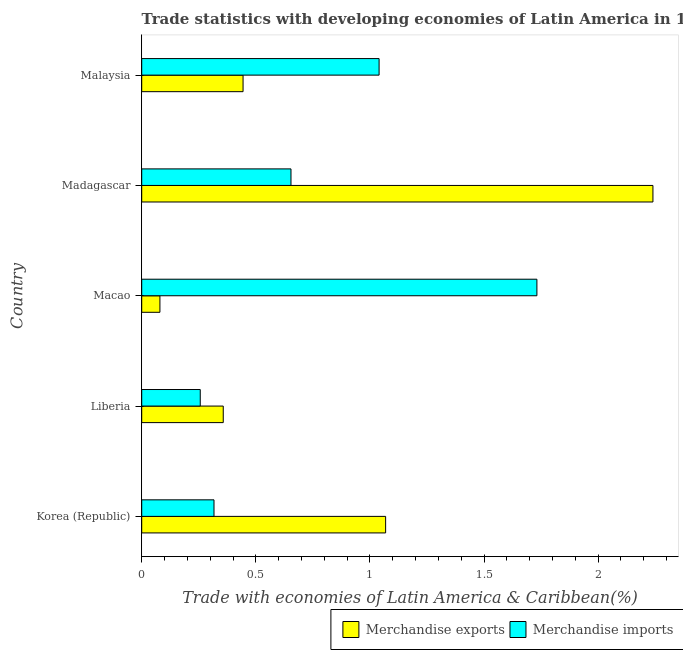How many different coloured bars are there?
Keep it short and to the point. 2. How many groups of bars are there?
Your answer should be compact. 5. How many bars are there on the 1st tick from the bottom?
Keep it short and to the point. 2. What is the label of the 5th group of bars from the top?
Your response must be concise. Korea (Republic). What is the merchandise imports in Liberia?
Offer a very short reply. 0.26. Across all countries, what is the maximum merchandise exports?
Ensure brevity in your answer.  2.24. Across all countries, what is the minimum merchandise exports?
Ensure brevity in your answer.  0.08. In which country was the merchandise imports maximum?
Make the answer very short. Macao. In which country was the merchandise exports minimum?
Ensure brevity in your answer.  Macao. What is the total merchandise imports in the graph?
Your answer should be compact. 4. What is the difference between the merchandise imports in Liberia and that in Malaysia?
Your answer should be compact. -0.78. What is the difference between the merchandise imports in Malaysia and the merchandise exports in Macao?
Offer a very short reply. 0.96. What is the average merchandise exports per country?
Make the answer very short. 0.84. What is the difference between the merchandise exports and merchandise imports in Madagascar?
Offer a very short reply. 1.59. What is the ratio of the merchandise exports in Liberia to that in Malaysia?
Make the answer very short. 0.81. Is the merchandise imports in Korea (Republic) less than that in Madagascar?
Provide a succinct answer. Yes. Is the difference between the merchandise imports in Korea (Republic) and Macao greater than the difference between the merchandise exports in Korea (Republic) and Macao?
Make the answer very short. No. What is the difference between the highest and the second highest merchandise exports?
Give a very brief answer. 1.17. What is the difference between the highest and the lowest merchandise exports?
Your answer should be compact. 2.16. In how many countries, is the merchandise imports greater than the average merchandise imports taken over all countries?
Offer a very short reply. 2. What does the 2nd bar from the top in Liberia represents?
Your response must be concise. Merchandise exports. What does the 2nd bar from the bottom in Madagascar represents?
Provide a succinct answer. Merchandise imports. How many bars are there?
Your response must be concise. 10. Are all the bars in the graph horizontal?
Ensure brevity in your answer.  Yes. How many countries are there in the graph?
Ensure brevity in your answer.  5. Are the values on the major ticks of X-axis written in scientific E-notation?
Your answer should be very brief. No. Does the graph contain any zero values?
Keep it short and to the point. No. Does the graph contain grids?
Your answer should be compact. No. How many legend labels are there?
Offer a terse response. 2. What is the title of the graph?
Offer a very short reply. Trade statistics with developing economies of Latin America in 1977. What is the label or title of the X-axis?
Ensure brevity in your answer.  Trade with economies of Latin America & Caribbean(%). What is the Trade with economies of Latin America & Caribbean(%) of Merchandise exports in Korea (Republic)?
Make the answer very short. 1.07. What is the Trade with economies of Latin America & Caribbean(%) of Merchandise imports in Korea (Republic)?
Your answer should be compact. 0.32. What is the Trade with economies of Latin America & Caribbean(%) in Merchandise exports in Liberia?
Ensure brevity in your answer.  0.36. What is the Trade with economies of Latin America & Caribbean(%) of Merchandise imports in Liberia?
Offer a terse response. 0.26. What is the Trade with economies of Latin America & Caribbean(%) in Merchandise exports in Macao?
Give a very brief answer. 0.08. What is the Trade with economies of Latin America & Caribbean(%) in Merchandise imports in Macao?
Offer a terse response. 1.73. What is the Trade with economies of Latin America & Caribbean(%) in Merchandise exports in Madagascar?
Offer a very short reply. 2.24. What is the Trade with economies of Latin America & Caribbean(%) of Merchandise imports in Madagascar?
Keep it short and to the point. 0.65. What is the Trade with economies of Latin America & Caribbean(%) of Merchandise exports in Malaysia?
Your answer should be very brief. 0.44. What is the Trade with economies of Latin America & Caribbean(%) of Merchandise imports in Malaysia?
Ensure brevity in your answer.  1.04. Across all countries, what is the maximum Trade with economies of Latin America & Caribbean(%) of Merchandise exports?
Offer a very short reply. 2.24. Across all countries, what is the maximum Trade with economies of Latin America & Caribbean(%) of Merchandise imports?
Make the answer very short. 1.73. Across all countries, what is the minimum Trade with economies of Latin America & Caribbean(%) in Merchandise exports?
Your answer should be compact. 0.08. Across all countries, what is the minimum Trade with economies of Latin America & Caribbean(%) in Merchandise imports?
Your answer should be compact. 0.26. What is the total Trade with economies of Latin America & Caribbean(%) of Merchandise exports in the graph?
Offer a terse response. 4.19. What is the total Trade with economies of Latin America & Caribbean(%) of Merchandise imports in the graph?
Give a very brief answer. 4. What is the difference between the Trade with economies of Latin America & Caribbean(%) in Merchandise exports in Korea (Republic) and that in Liberia?
Your response must be concise. 0.71. What is the difference between the Trade with economies of Latin America & Caribbean(%) of Merchandise imports in Korea (Republic) and that in Liberia?
Provide a short and direct response. 0.06. What is the difference between the Trade with economies of Latin America & Caribbean(%) in Merchandise imports in Korea (Republic) and that in Macao?
Offer a very short reply. -1.42. What is the difference between the Trade with economies of Latin America & Caribbean(%) of Merchandise exports in Korea (Republic) and that in Madagascar?
Provide a succinct answer. -1.17. What is the difference between the Trade with economies of Latin America & Caribbean(%) of Merchandise imports in Korea (Republic) and that in Madagascar?
Provide a short and direct response. -0.34. What is the difference between the Trade with economies of Latin America & Caribbean(%) of Merchandise exports in Korea (Republic) and that in Malaysia?
Your answer should be very brief. 0.62. What is the difference between the Trade with economies of Latin America & Caribbean(%) of Merchandise imports in Korea (Republic) and that in Malaysia?
Your answer should be very brief. -0.72. What is the difference between the Trade with economies of Latin America & Caribbean(%) of Merchandise exports in Liberia and that in Macao?
Make the answer very short. 0.28. What is the difference between the Trade with economies of Latin America & Caribbean(%) of Merchandise imports in Liberia and that in Macao?
Offer a terse response. -1.48. What is the difference between the Trade with economies of Latin America & Caribbean(%) of Merchandise exports in Liberia and that in Madagascar?
Your response must be concise. -1.88. What is the difference between the Trade with economies of Latin America & Caribbean(%) in Merchandise imports in Liberia and that in Madagascar?
Your answer should be very brief. -0.4. What is the difference between the Trade with economies of Latin America & Caribbean(%) of Merchandise exports in Liberia and that in Malaysia?
Ensure brevity in your answer.  -0.09. What is the difference between the Trade with economies of Latin America & Caribbean(%) in Merchandise imports in Liberia and that in Malaysia?
Offer a terse response. -0.78. What is the difference between the Trade with economies of Latin America & Caribbean(%) of Merchandise exports in Macao and that in Madagascar?
Provide a short and direct response. -2.16. What is the difference between the Trade with economies of Latin America & Caribbean(%) of Merchandise imports in Macao and that in Madagascar?
Make the answer very short. 1.08. What is the difference between the Trade with economies of Latin America & Caribbean(%) of Merchandise exports in Macao and that in Malaysia?
Offer a very short reply. -0.36. What is the difference between the Trade with economies of Latin America & Caribbean(%) in Merchandise imports in Macao and that in Malaysia?
Your answer should be compact. 0.69. What is the difference between the Trade with economies of Latin America & Caribbean(%) in Merchandise exports in Madagascar and that in Malaysia?
Offer a very short reply. 1.8. What is the difference between the Trade with economies of Latin America & Caribbean(%) in Merchandise imports in Madagascar and that in Malaysia?
Your answer should be compact. -0.39. What is the difference between the Trade with economies of Latin America & Caribbean(%) in Merchandise exports in Korea (Republic) and the Trade with economies of Latin America & Caribbean(%) in Merchandise imports in Liberia?
Your answer should be very brief. 0.81. What is the difference between the Trade with economies of Latin America & Caribbean(%) in Merchandise exports in Korea (Republic) and the Trade with economies of Latin America & Caribbean(%) in Merchandise imports in Macao?
Provide a succinct answer. -0.66. What is the difference between the Trade with economies of Latin America & Caribbean(%) of Merchandise exports in Korea (Republic) and the Trade with economies of Latin America & Caribbean(%) of Merchandise imports in Madagascar?
Your answer should be very brief. 0.41. What is the difference between the Trade with economies of Latin America & Caribbean(%) in Merchandise exports in Korea (Republic) and the Trade with economies of Latin America & Caribbean(%) in Merchandise imports in Malaysia?
Provide a succinct answer. 0.03. What is the difference between the Trade with economies of Latin America & Caribbean(%) in Merchandise exports in Liberia and the Trade with economies of Latin America & Caribbean(%) in Merchandise imports in Macao?
Give a very brief answer. -1.37. What is the difference between the Trade with economies of Latin America & Caribbean(%) in Merchandise exports in Liberia and the Trade with economies of Latin America & Caribbean(%) in Merchandise imports in Madagascar?
Your answer should be very brief. -0.3. What is the difference between the Trade with economies of Latin America & Caribbean(%) of Merchandise exports in Liberia and the Trade with economies of Latin America & Caribbean(%) of Merchandise imports in Malaysia?
Provide a short and direct response. -0.68. What is the difference between the Trade with economies of Latin America & Caribbean(%) of Merchandise exports in Macao and the Trade with economies of Latin America & Caribbean(%) of Merchandise imports in Madagascar?
Offer a terse response. -0.57. What is the difference between the Trade with economies of Latin America & Caribbean(%) in Merchandise exports in Macao and the Trade with economies of Latin America & Caribbean(%) in Merchandise imports in Malaysia?
Your answer should be very brief. -0.96. What is the difference between the Trade with economies of Latin America & Caribbean(%) of Merchandise exports in Madagascar and the Trade with economies of Latin America & Caribbean(%) of Merchandise imports in Malaysia?
Ensure brevity in your answer.  1.2. What is the average Trade with economies of Latin America & Caribbean(%) of Merchandise exports per country?
Your response must be concise. 0.84. What is the average Trade with economies of Latin America & Caribbean(%) of Merchandise imports per country?
Offer a very short reply. 0.8. What is the difference between the Trade with economies of Latin America & Caribbean(%) in Merchandise exports and Trade with economies of Latin America & Caribbean(%) in Merchandise imports in Korea (Republic)?
Provide a succinct answer. 0.75. What is the difference between the Trade with economies of Latin America & Caribbean(%) in Merchandise exports and Trade with economies of Latin America & Caribbean(%) in Merchandise imports in Liberia?
Keep it short and to the point. 0.1. What is the difference between the Trade with economies of Latin America & Caribbean(%) of Merchandise exports and Trade with economies of Latin America & Caribbean(%) of Merchandise imports in Macao?
Make the answer very short. -1.65. What is the difference between the Trade with economies of Latin America & Caribbean(%) in Merchandise exports and Trade with economies of Latin America & Caribbean(%) in Merchandise imports in Madagascar?
Your answer should be compact. 1.59. What is the difference between the Trade with economies of Latin America & Caribbean(%) in Merchandise exports and Trade with economies of Latin America & Caribbean(%) in Merchandise imports in Malaysia?
Keep it short and to the point. -0.6. What is the ratio of the Trade with economies of Latin America & Caribbean(%) in Merchandise exports in Korea (Republic) to that in Liberia?
Keep it short and to the point. 2.99. What is the ratio of the Trade with economies of Latin America & Caribbean(%) of Merchandise imports in Korea (Republic) to that in Liberia?
Offer a terse response. 1.23. What is the ratio of the Trade with economies of Latin America & Caribbean(%) of Merchandise exports in Korea (Republic) to that in Macao?
Offer a terse response. 13.4. What is the ratio of the Trade with economies of Latin America & Caribbean(%) of Merchandise imports in Korea (Republic) to that in Macao?
Your answer should be very brief. 0.18. What is the ratio of the Trade with economies of Latin America & Caribbean(%) of Merchandise exports in Korea (Republic) to that in Madagascar?
Offer a terse response. 0.48. What is the ratio of the Trade with economies of Latin America & Caribbean(%) of Merchandise imports in Korea (Republic) to that in Madagascar?
Make the answer very short. 0.48. What is the ratio of the Trade with economies of Latin America & Caribbean(%) of Merchandise exports in Korea (Republic) to that in Malaysia?
Keep it short and to the point. 2.41. What is the ratio of the Trade with economies of Latin America & Caribbean(%) of Merchandise imports in Korea (Republic) to that in Malaysia?
Your answer should be very brief. 0.3. What is the ratio of the Trade with economies of Latin America & Caribbean(%) of Merchandise exports in Liberia to that in Macao?
Your answer should be very brief. 4.48. What is the ratio of the Trade with economies of Latin America & Caribbean(%) of Merchandise imports in Liberia to that in Macao?
Your answer should be very brief. 0.15. What is the ratio of the Trade with economies of Latin America & Caribbean(%) in Merchandise exports in Liberia to that in Madagascar?
Make the answer very short. 0.16. What is the ratio of the Trade with economies of Latin America & Caribbean(%) in Merchandise imports in Liberia to that in Madagascar?
Your answer should be compact. 0.39. What is the ratio of the Trade with economies of Latin America & Caribbean(%) in Merchandise exports in Liberia to that in Malaysia?
Your answer should be compact. 0.8. What is the ratio of the Trade with economies of Latin America & Caribbean(%) in Merchandise imports in Liberia to that in Malaysia?
Provide a succinct answer. 0.25. What is the ratio of the Trade with economies of Latin America & Caribbean(%) in Merchandise exports in Macao to that in Madagascar?
Offer a terse response. 0.04. What is the ratio of the Trade with economies of Latin America & Caribbean(%) in Merchandise imports in Macao to that in Madagascar?
Make the answer very short. 2.65. What is the ratio of the Trade with economies of Latin America & Caribbean(%) in Merchandise exports in Macao to that in Malaysia?
Ensure brevity in your answer.  0.18. What is the ratio of the Trade with economies of Latin America & Caribbean(%) in Merchandise imports in Macao to that in Malaysia?
Your response must be concise. 1.66. What is the ratio of the Trade with economies of Latin America & Caribbean(%) of Merchandise exports in Madagascar to that in Malaysia?
Provide a succinct answer. 5.04. What is the ratio of the Trade with economies of Latin America & Caribbean(%) of Merchandise imports in Madagascar to that in Malaysia?
Give a very brief answer. 0.63. What is the difference between the highest and the second highest Trade with economies of Latin America & Caribbean(%) of Merchandise exports?
Provide a succinct answer. 1.17. What is the difference between the highest and the second highest Trade with economies of Latin America & Caribbean(%) of Merchandise imports?
Your response must be concise. 0.69. What is the difference between the highest and the lowest Trade with economies of Latin America & Caribbean(%) in Merchandise exports?
Offer a terse response. 2.16. What is the difference between the highest and the lowest Trade with economies of Latin America & Caribbean(%) in Merchandise imports?
Your response must be concise. 1.48. 